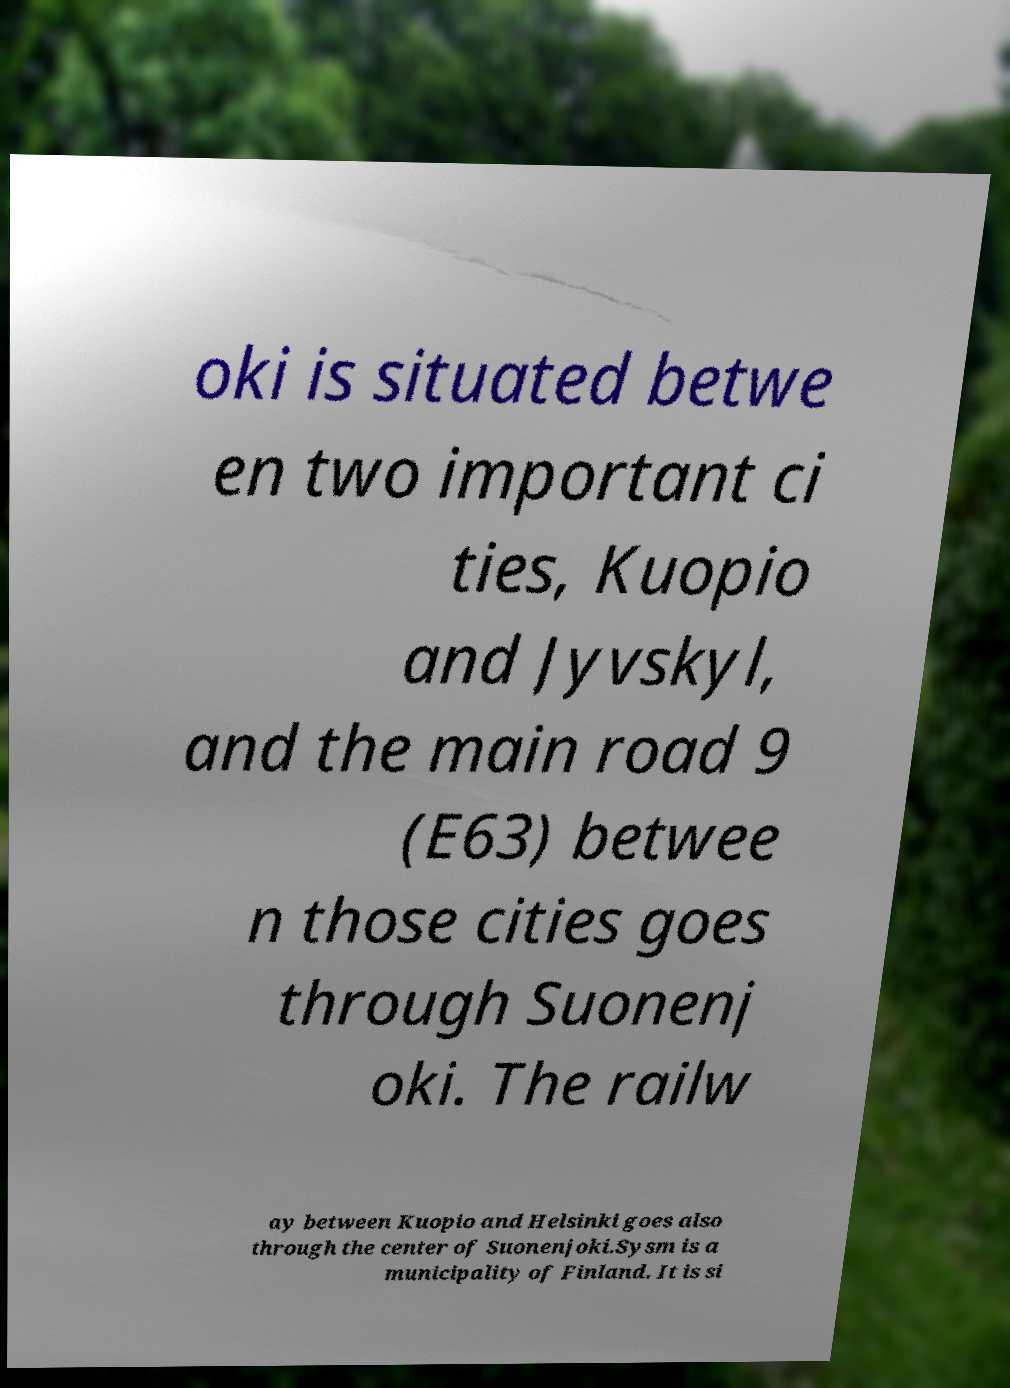Could you extract and type out the text from this image? oki is situated betwe en two important ci ties, Kuopio and Jyvskyl, and the main road 9 (E63) betwee n those cities goes through Suonenj oki. The railw ay between Kuopio and Helsinki goes also through the center of Suonenjoki.Sysm is a municipality of Finland. It is si 